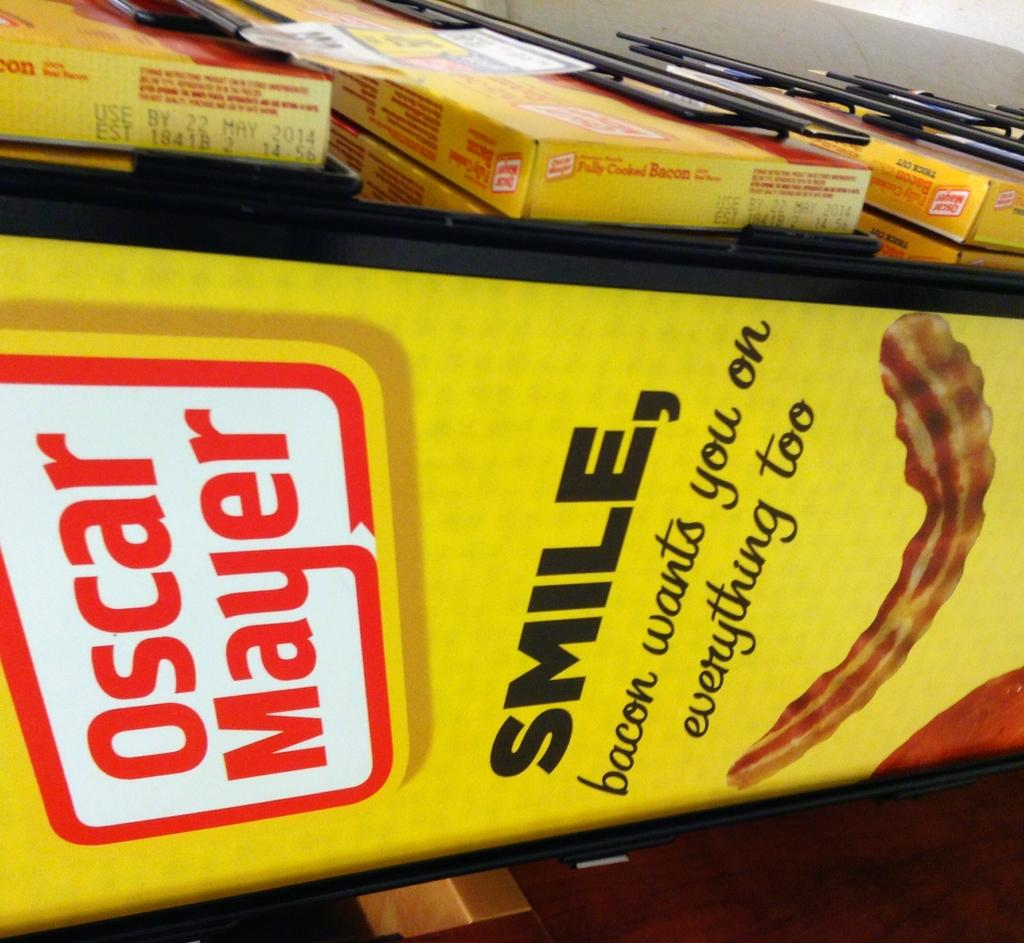What is hanging in the image? There is a banner in the image. What else can be seen in the image besides the banner? There are boxes in the image. What is written on the banner? There is writing on the banner. What type of bait is being used to catch fish in the image? There is no bait or fishing activity present in the image; it features a banner and boxes. Can you tell me how many potatoes are visible in the image? There are no potatoes present in the image. 